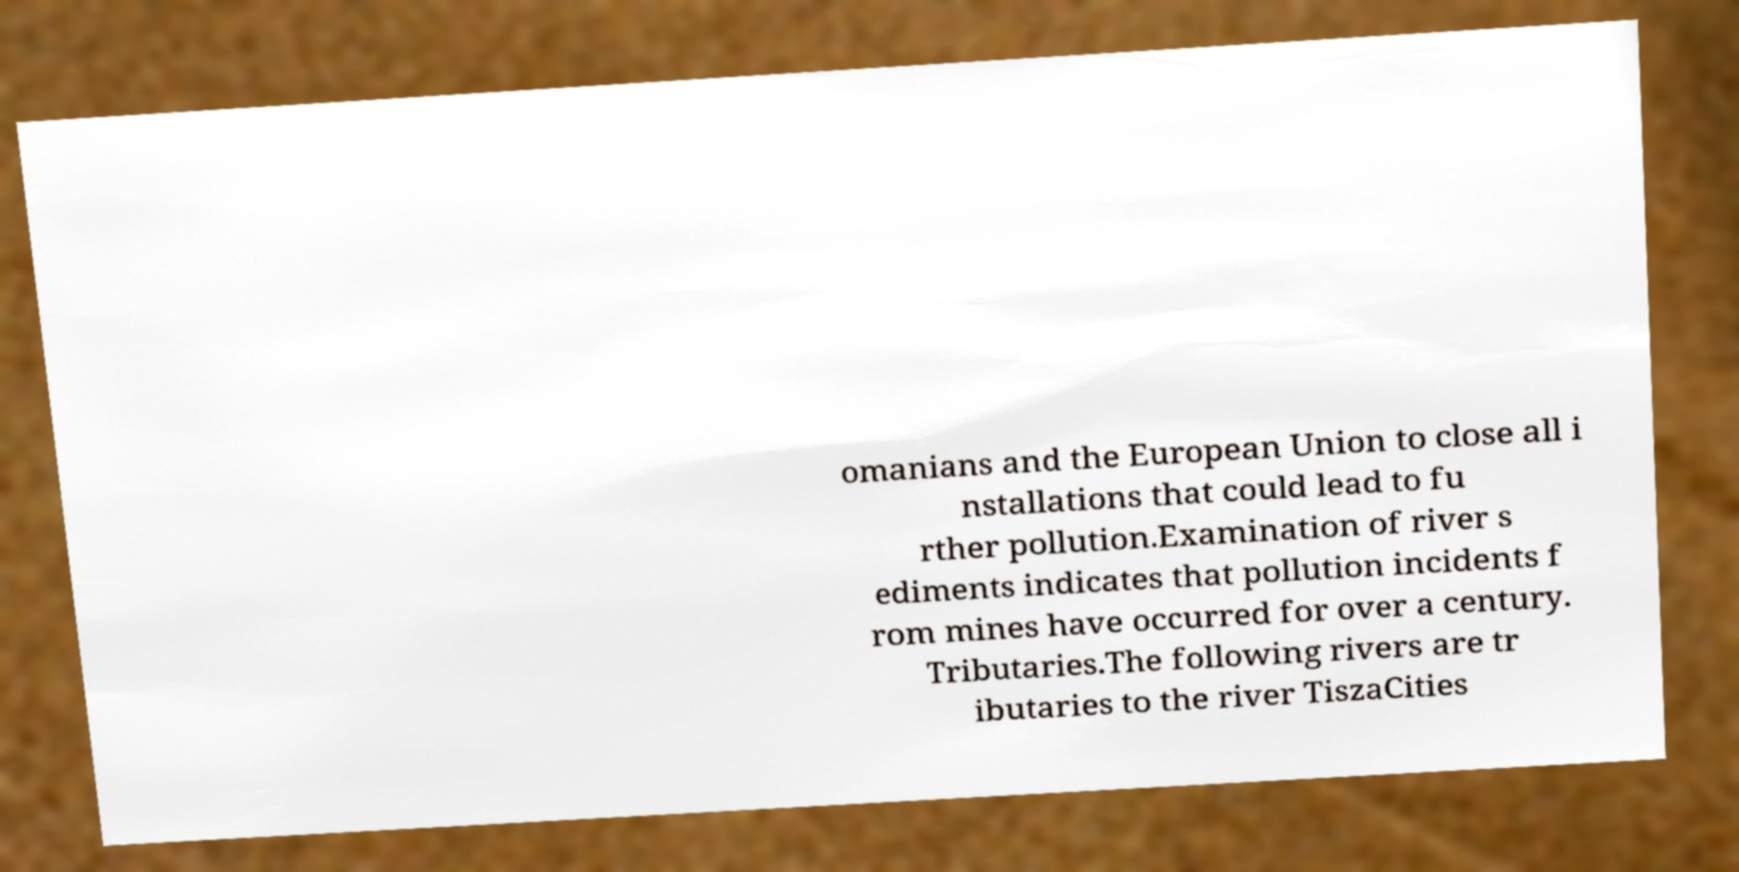There's text embedded in this image that I need extracted. Can you transcribe it verbatim? omanians and the European Union to close all i nstallations that could lead to fu rther pollution.Examination of river s ediments indicates that pollution incidents f rom mines have occurred for over a century. Tributaries.The following rivers are tr ibutaries to the river TiszaCities 